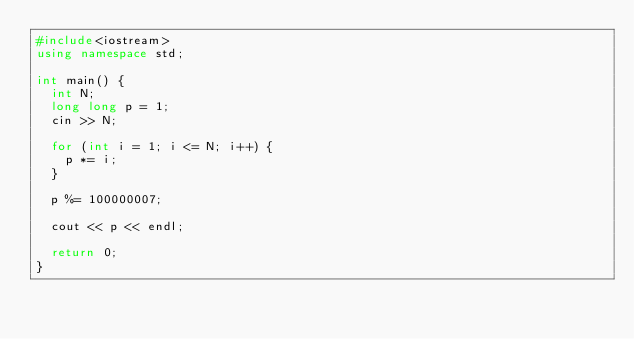Convert code to text. <code><loc_0><loc_0><loc_500><loc_500><_C++_>#include<iostream>
using namespace std;

int main() {
  int N;
  long long p = 1;
  cin >> N;

  for (int i = 1; i <= N; i++) {
    p *= i;
  }

  p %= 100000007;

  cout << p << endl;
  
  return 0;
}
</code> 